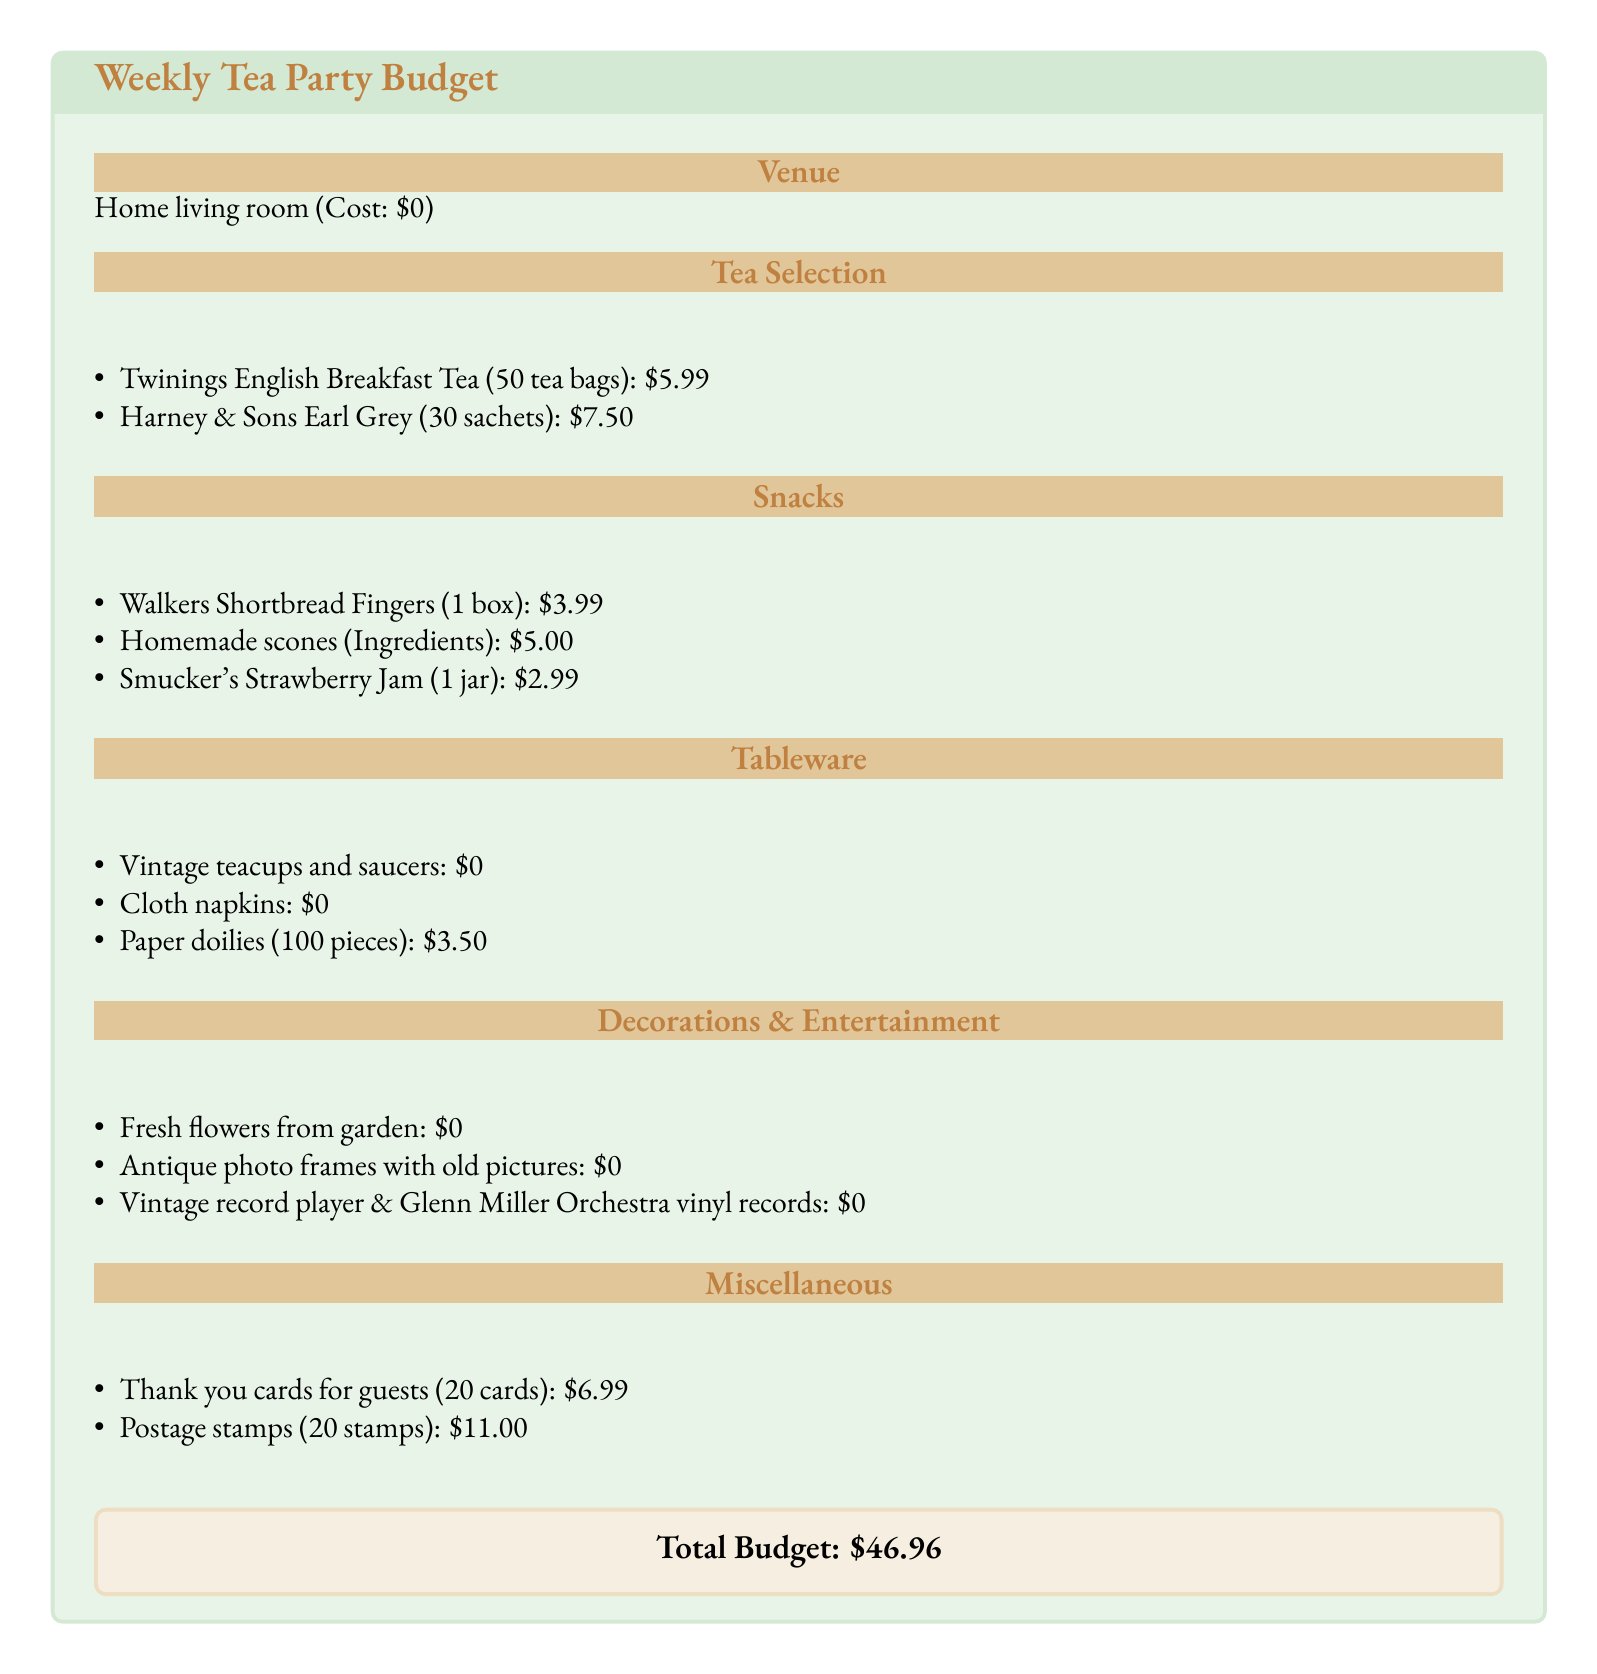what is the cost of Twinings English Breakfast Tea? The cost of Twinings English Breakfast Tea is specifically stated in the document as $5.99.
Answer: $5.99 how much do the thank you cards cost? The cost of the thank you cards for guests is mentioned in the miscellaneous section as $6.99.
Answer: $6.99 what is the total budget for hosting the tea parties? The total budget is presented in a special box at the end of the document, stating it as $46.96.
Answer: $46.96 how many pieces are in the paper doilies pack? The document specifies that the pack of paper doilies contains 100 pieces.
Answer: 100 pieces what is the cost for the homemade scones ingredients? The ingredients for homemade scones are stated in the snacks section with a cost of $5.00.
Answer: $5.00 what are the sources of entertainment listed? The entertainment sources include an antique photo frame with old pictures and a vintage record player with Glenn Miller Orchestra vinyl records.
Answer: Antique photo frames and vintage record player how much does it cost to send 20 stamps? The postage stamps for sending 20 stamps are indicated to cost $11.00 in the miscellaneous section.
Answer: $11.00 what decoration comes from the garden? The document lists fresh flowers from the garden as a source of decoration for the tea party.
Answer: Fresh flowers 